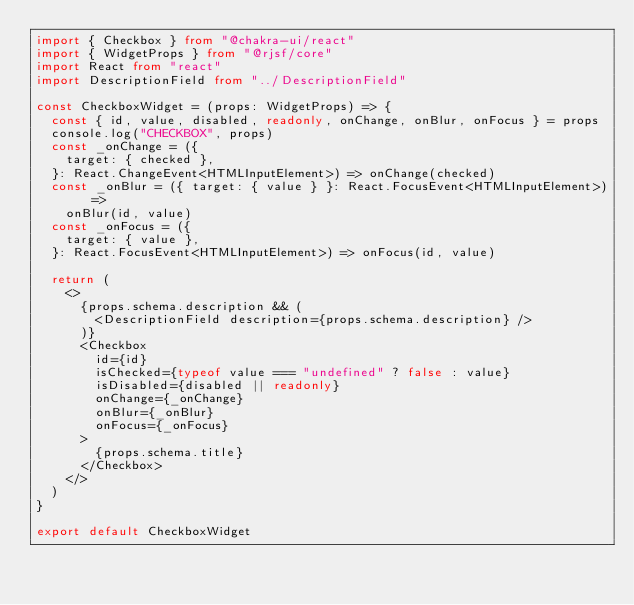Convert code to text. <code><loc_0><loc_0><loc_500><loc_500><_TypeScript_>import { Checkbox } from "@chakra-ui/react"
import { WidgetProps } from "@rjsf/core"
import React from "react"
import DescriptionField from "../DescriptionField"

const CheckboxWidget = (props: WidgetProps) => {
  const { id, value, disabled, readonly, onChange, onBlur, onFocus } = props
  console.log("CHECKBOX", props)
  const _onChange = ({
    target: { checked },
  }: React.ChangeEvent<HTMLInputElement>) => onChange(checked)
  const _onBlur = ({ target: { value } }: React.FocusEvent<HTMLInputElement>) =>
    onBlur(id, value)
  const _onFocus = ({
    target: { value },
  }: React.FocusEvent<HTMLInputElement>) => onFocus(id, value)

  return (
    <>
      {props.schema.description && (
        <DescriptionField description={props.schema.description} />
      )}
      <Checkbox
        id={id}
        isChecked={typeof value === "undefined" ? false : value}
        isDisabled={disabled || readonly}
        onChange={_onChange}
        onBlur={_onBlur}
        onFocus={_onFocus}
      >
        {props.schema.title}
      </Checkbox>
    </>
  )
}

export default CheckboxWidget
</code> 